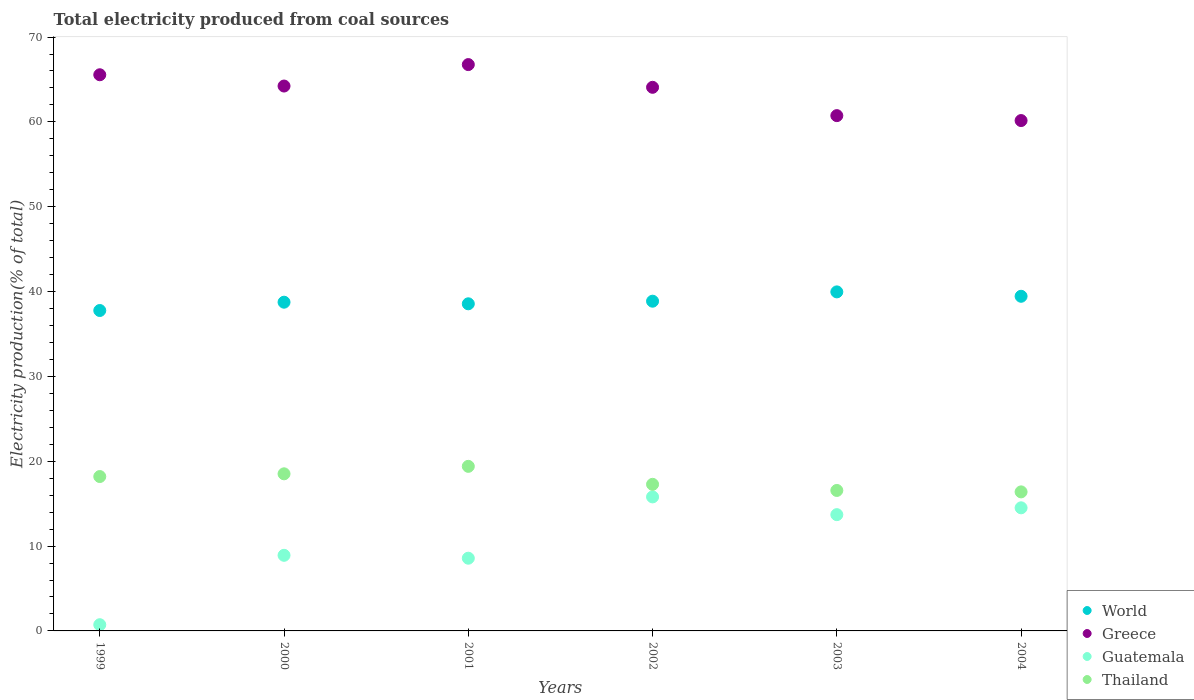Is the number of dotlines equal to the number of legend labels?
Your response must be concise. Yes. What is the total electricity produced in Guatemala in 2000?
Keep it short and to the point. 8.91. Across all years, what is the maximum total electricity produced in Guatemala?
Provide a short and direct response. 15.8. Across all years, what is the minimum total electricity produced in Thailand?
Your answer should be very brief. 16.39. In which year was the total electricity produced in Guatemala maximum?
Ensure brevity in your answer.  2002. In which year was the total electricity produced in World minimum?
Your response must be concise. 1999. What is the total total electricity produced in Guatemala in the graph?
Give a very brief answer. 62.23. What is the difference between the total electricity produced in Thailand in 1999 and that in 2004?
Provide a succinct answer. 1.81. What is the difference between the total electricity produced in Guatemala in 2004 and the total electricity produced in Thailand in 2002?
Make the answer very short. -2.77. What is the average total electricity produced in Thailand per year?
Offer a terse response. 17.72. In the year 2002, what is the difference between the total electricity produced in Guatemala and total electricity produced in Thailand?
Make the answer very short. -1.48. In how many years, is the total electricity produced in Guatemala greater than 42 %?
Give a very brief answer. 0. What is the ratio of the total electricity produced in Guatemala in 2002 to that in 2004?
Offer a terse response. 1.09. Is the total electricity produced in Greece in 2000 less than that in 2002?
Keep it short and to the point. No. Is the difference between the total electricity produced in Guatemala in 2000 and 2001 greater than the difference between the total electricity produced in Thailand in 2000 and 2001?
Offer a very short reply. Yes. What is the difference between the highest and the second highest total electricity produced in Guatemala?
Offer a terse response. 1.29. What is the difference between the highest and the lowest total electricity produced in Thailand?
Offer a terse response. 3.01. Is it the case that in every year, the sum of the total electricity produced in Thailand and total electricity produced in World  is greater than the sum of total electricity produced in Greece and total electricity produced in Guatemala?
Your answer should be compact. Yes. Is the total electricity produced in Guatemala strictly less than the total electricity produced in World over the years?
Your response must be concise. Yes. How many dotlines are there?
Make the answer very short. 4. How many years are there in the graph?
Provide a short and direct response. 6. Does the graph contain grids?
Offer a very short reply. No. Where does the legend appear in the graph?
Offer a very short reply. Bottom right. How many legend labels are there?
Your answer should be very brief. 4. What is the title of the graph?
Make the answer very short. Total electricity produced from coal sources. Does "Lesotho" appear as one of the legend labels in the graph?
Provide a succinct answer. No. What is the Electricity production(% of total) of World in 1999?
Provide a succinct answer. 37.77. What is the Electricity production(% of total) in Greece in 1999?
Provide a succinct answer. 65.56. What is the Electricity production(% of total) of Guatemala in 1999?
Give a very brief answer. 0.73. What is the Electricity production(% of total) in Thailand in 1999?
Your answer should be very brief. 18.2. What is the Electricity production(% of total) of World in 2000?
Provide a short and direct response. 38.75. What is the Electricity production(% of total) in Greece in 2000?
Your answer should be compact. 64.23. What is the Electricity production(% of total) in Guatemala in 2000?
Your answer should be compact. 8.91. What is the Electricity production(% of total) in Thailand in 2000?
Your answer should be very brief. 18.52. What is the Electricity production(% of total) of World in 2001?
Keep it short and to the point. 38.56. What is the Electricity production(% of total) of Greece in 2001?
Make the answer very short. 66.76. What is the Electricity production(% of total) in Guatemala in 2001?
Make the answer very short. 8.57. What is the Electricity production(% of total) in Thailand in 2001?
Make the answer very short. 19.4. What is the Electricity production(% of total) in World in 2002?
Make the answer very short. 38.86. What is the Electricity production(% of total) of Greece in 2002?
Your answer should be very brief. 64.08. What is the Electricity production(% of total) in Guatemala in 2002?
Your answer should be very brief. 15.8. What is the Electricity production(% of total) of Thailand in 2002?
Your response must be concise. 17.28. What is the Electricity production(% of total) in World in 2003?
Your answer should be compact. 39.96. What is the Electricity production(% of total) in Greece in 2003?
Your answer should be very brief. 60.74. What is the Electricity production(% of total) in Guatemala in 2003?
Make the answer very short. 13.71. What is the Electricity production(% of total) of Thailand in 2003?
Your answer should be very brief. 16.56. What is the Electricity production(% of total) of World in 2004?
Your answer should be very brief. 39.44. What is the Electricity production(% of total) in Greece in 2004?
Your answer should be very brief. 60.16. What is the Electricity production(% of total) in Guatemala in 2004?
Give a very brief answer. 14.51. What is the Electricity production(% of total) of Thailand in 2004?
Provide a succinct answer. 16.39. Across all years, what is the maximum Electricity production(% of total) in World?
Provide a short and direct response. 39.96. Across all years, what is the maximum Electricity production(% of total) of Greece?
Keep it short and to the point. 66.76. Across all years, what is the maximum Electricity production(% of total) of Guatemala?
Your response must be concise. 15.8. Across all years, what is the maximum Electricity production(% of total) in Thailand?
Provide a short and direct response. 19.4. Across all years, what is the minimum Electricity production(% of total) of World?
Your response must be concise. 37.77. Across all years, what is the minimum Electricity production(% of total) of Greece?
Ensure brevity in your answer.  60.16. Across all years, what is the minimum Electricity production(% of total) in Guatemala?
Provide a succinct answer. 0.73. Across all years, what is the minimum Electricity production(% of total) of Thailand?
Give a very brief answer. 16.39. What is the total Electricity production(% of total) in World in the graph?
Provide a short and direct response. 233.34. What is the total Electricity production(% of total) in Greece in the graph?
Your answer should be very brief. 381.51. What is the total Electricity production(% of total) in Guatemala in the graph?
Keep it short and to the point. 62.23. What is the total Electricity production(% of total) in Thailand in the graph?
Your answer should be compact. 106.34. What is the difference between the Electricity production(% of total) of World in 1999 and that in 2000?
Your answer should be compact. -0.98. What is the difference between the Electricity production(% of total) in Greece in 1999 and that in 2000?
Provide a short and direct response. 1.33. What is the difference between the Electricity production(% of total) in Guatemala in 1999 and that in 2000?
Offer a terse response. -8.18. What is the difference between the Electricity production(% of total) of Thailand in 1999 and that in 2000?
Your answer should be compact. -0.32. What is the difference between the Electricity production(% of total) in World in 1999 and that in 2001?
Offer a terse response. -0.79. What is the difference between the Electricity production(% of total) of Greece in 1999 and that in 2001?
Provide a short and direct response. -1.2. What is the difference between the Electricity production(% of total) of Guatemala in 1999 and that in 2001?
Ensure brevity in your answer.  -7.84. What is the difference between the Electricity production(% of total) in Thailand in 1999 and that in 2001?
Your answer should be compact. -1.2. What is the difference between the Electricity production(% of total) in World in 1999 and that in 2002?
Give a very brief answer. -1.1. What is the difference between the Electricity production(% of total) of Greece in 1999 and that in 2002?
Ensure brevity in your answer.  1.48. What is the difference between the Electricity production(% of total) of Guatemala in 1999 and that in 2002?
Ensure brevity in your answer.  -15.06. What is the difference between the Electricity production(% of total) in Thailand in 1999 and that in 2002?
Give a very brief answer. 0.92. What is the difference between the Electricity production(% of total) of World in 1999 and that in 2003?
Offer a very short reply. -2.19. What is the difference between the Electricity production(% of total) of Greece in 1999 and that in 2003?
Keep it short and to the point. 4.82. What is the difference between the Electricity production(% of total) of Guatemala in 1999 and that in 2003?
Provide a succinct answer. -12.97. What is the difference between the Electricity production(% of total) of Thailand in 1999 and that in 2003?
Provide a short and direct response. 1.64. What is the difference between the Electricity production(% of total) of World in 1999 and that in 2004?
Your response must be concise. -1.68. What is the difference between the Electricity production(% of total) of Greece in 1999 and that in 2004?
Give a very brief answer. 5.4. What is the difference between the Electricity production(% of total) of Guatemala in 1999 and that in 2004?
Keep it short and to the point. -13.78. What is the difference between the Electricity production(% of total) of Thailand in 1999 and that in 2004?
Your answer should be compact. 1.81. What is the difference between the Electricity production(% of total) in World in 2000 and that in 2001?
Provide a short and direct response. 0.19. What is the difference between the Electricity production(% of total) in Greece in 2000 and that in 2001?
Make the answer very short. -2.53. What is the difference between the Electricity production(% of total) in Guatemala in 2000 and that in 2001?
Provide a short and direct response. 0.34. What is the difference between the Electricity production(% of total) of Thailand in 2000 and that in 2001?
Provide a short and direct response. -0.88. What is the difference between the Electricity production(% of total) in World in 2000 and that in 2002?
Offer a very short reply. -0.12. What is the difference between the Electricity production(% of total) of Greece in 2000 and that in 2002?
Provide a short and direct response. 0.15. What is the difference between the Electricity production(% of total) of Guatemala in 2000 and that in 2002?
Make the answer very short. -6.89. What is the difference between the Electricity production(% of total) of Thailand in 2000 and that in 2002?
Keep it short and to the point. 1.24. What is the difference between the Electricity production(% of total) of World in 2000 and that in 2003?
Make the answer very short. -1.22. What is the difference between the Electricity production(% of total) of Greece in 2000 and that in 2003?
Your answer should be very brief. 3.49. What is the difference between the Electricity production(% of total) of Guatemala in 2000 and that in 2003?
Your answer should be very brief. -4.79. What is the difference between the Electricity production(% of total) of Thailand in 2000 and that in 2003?
Offer a very short reply. 1.96. What is the difference between the Electricity production(% of total) in World in 2000 and that in 2004?
Ensure brevity in your answer.  -0.7. What is the difference between the Electricity production(% of total) in Greece in 2000 and that in 2004?
Give a very brief answer. 4.07. What is the difference between the Electricity production(% of total) of Guatemala in 2000 and that in 2004?
Ensure brevity in your answer.  -5.6. What is the difference between the Electricity production(% of total) in Thailand in 2000 and that in 2004?
Your answer should be very brief. 2.13. What is the difference between the Electricity production(% of total) of World in 2001 and that in 2002?
Your response must be concise. -0.31. What is the difference between the Electricity production(% of total) of Greece in 2001 and that in 2002?
Provide a short and direct response. 2.68. What is the difference between the Electricity production(% of total) in Guatemala in 2001 and that in 2002?
Offer a very short reply. -7.23. What is the difference between the Electricity production(% of total) of Thailand in 2001 and that in 2002?
Your answer should be very brief. 2.12. What is the difference between the Electricity production(% of total) of World in 2001 and that in 2003?
Offer a terse response. -1.4. What is the difference between the Electricity production(% of total) in Greece in 2001 and that in 2003?
Your response must be concise. 6.02. What is the difference between the Electricity production(% of total) of Guatemala in 2001 and that in 2003?
Ensure brevity in your answer.  -5.13. What is the difference between the Electricity production(% of total) of Thailand in 2001 and that in 2003?
Provide a succinct answer. 2.84. What is the difference between the Electricity production(% of total) in World in 2001 and that in 2004?
Ensure brevity in your answer.  -0.89. What is the difference between the Electricity production(% of total) of Greece in 2001 and that in 2004?
Keep it short and to the point. 6.6. What is the difference between the Electricity production(% of total) of Guatemala in 2001 and that in 2004?
Your answer should be very brief. -5.94. What is the difference between the Electricity production(% of total) in Thailand in 2001 and that in 2004?
Your response must be concise. 3.01. What is the difference between the Electricity production(% of total) in World in 2002 and that in 2003?
Offer a very short reply. -1.1. What is the difference between the Electricity production(% of total) of Greece in 2002 and that in 2003?
Ensure brevity in your answer.  3.34. What is the difference between the Electricity production(% of total) of Guatemala in 2002 and that in 2003?
Provide a short and direct response. 2.09. What is the difference between the Electricity production(% of total) of Thailand in 2002 and that in 2003?
Your answer should be very brief. 0.72. What is the difference between the Electricity production(% of total) of World in 2002 and that in 2004?
Give a very brief answer. -0.58. What is the difference between the Electricity production(% of total) of Greece in 2002 and that in 2004?
Provide a succinct answer. 3.92. What is the difference between the Electricity production(% of total) of Guatemala in 2002 and that in 2004?
Offer a terse response. 1.29. What is the difference between the Electricity production(% of total) in Thailand in 2002 and that in 2004?
Your answer should be compact. 0.89. What is the difference between the Electricity production(% of total) of World in 2003 and that in 2004?
Offer a very short reply. 0.52. What is the difference between the Electricity production(% of total) of Greece in 2003 and that in 2004?
Keep it short and to the point. 0.58. What is the difference between the Electricity production(% of total) in Guatemala in 2003 and that in 2004?
Provide a succinct answer. -0.81. What is the difference between the Electricity production(% of total) in Thailand in 2003 and that in 2004?
Provide a succinct answer. 0.17. What is the difference between the Electricity production(% of total) of World in 1999 and the Electricity production(% of total) of Greece in 2000?
Give a very brief answer. -26.46. What is the difference between the Electricity production(% of total) in World in 1999 and the Electricity production(% of total) in Guatemala in 2000?
Provide a short and direct response. 28.86. What is the difference between the Electricity production(% of total) of World in 1999 and the Electricity production(% of total) of Thailand in 2000?
Provide a succinct answer. 19.25. What is the difference between the Electricity production(% of total) in Greece in 1999 and the Electricity production(% of total) in Guatemala in 2000?
Your answer should be very brief. 56.64. What is the difference between the Electricity production(% of total) of Greece in 1999 and the Electricity production(% of total) of Thailand in 2000?
Offer a terse response. 47.04. What is the difference between the Electricity production(% of total) of Guatemala in 1999 and the Electricity production(% of total) of Thailand in 2000?
Keep it short and to the point. -17.78. What is the difference between the Electricity production(% of total) of World in 1999 and the Electricity production(% of total) of Greece in 2001?
Give a very brief answer. -28.99. What is the difference between the Electricity production(% of total) in World in 1999 and the Electricity production(% of total) in Guatemala in 2001?
Offer a terse response. 29.2. What is the difference between the Electricity production(% of total) in World in 1999 and the Electricity production(% of total) in Thailand in 2001?
Keep it short and to the point. 18.37. What is the difference between the Electricity production(% of total) of Greece in 1999 and the Electricity production(% of total) of Guatemala in 2001?
Provide a succinct answer. 56.98. What is the difference between the Electricity production(% of total) of Greece in 1999 and the Electricity production(% of total) of Thailand in 2001?
Ensure brevity in your answer.  46.16. What is the difference between the Electricity production(% of total) in Guatemala in 1999 and the Electricity production(% of total) in Thailand in 2001?
Provide a short and direct response. -18.67. What is the difference between the Electricity production(% of total) of World in 1999 and the Electricity production(% of total) of Greece in 2002?
Ensure brevity in your answer.  -26.31. What is the difference between the Electricity production(% of total) of World in 1999 and the Electricity production(% of total) of Guatemala in 2002?
Give a very brief answer. 21.97. What is the difference between the Electricity production(% of total) in World in 1999 and the Electricity production(% of total) in Thailand in 2002?
Provide a succinct answer. 20.49. What is the difference between the Electricity production(% of total) of Greece in 1999 and the Electricity production(% of total) of Guatemala in 2002?
Your answer should be compact. 49.76. What is the difference between the Electricity production(% of total) in Greece in 1999 and the Electricity production(% of total) in Thailand in 2002?
Keep it short and to the point. 48.28. What is the difference between the Electricity production(% of total) in Guatemala in 1999 and the Electricity production(% of total) in Thailand in 2002?
Keep it short and to the point. -16.55. What is the difference between the Electricity production(% of total) in World in 1999 and the Electricity production(% of total) in Greece in 2003?
Your answer should be compact. -22.97. What is the difference between the Electricity production(% of total) in World in 1999 and the Electricity production(% of total) in Guatemala in 2003?
Give a very brief answer. 24.06. What is the difference between the Electricity production(% of total) of World in 1999 and the Electricity production(% of total) of Thailand in 2003?
Your answer should be very brief. 21.21. What is the difference between the Electricity production(% of total) in Greece in 1999 and the Electricity production(% of total) in Guatemala in 2003?
Offer a terse response. 51.85. What is the difference between the Electricity production(% of total) of Greece in 1999 and the Electricity production(% of total) of Thailand in 2003?
Give a very brief answer. 49. What is the difference between the Electricity production(% of total) of Guatemala in 1999 and the Electricity production(% of total) of Thailand in 2003?
Your answer should be very brief. -15.82. What is the difference between the Electricity production(% of total) of World in 1999 and the Electricity production(% of total) of Greece in 2004?
Make the answer very short. -22.39. What is the difference between the Electricity production(% of total) of World in 1999 and the Electricity production(% of total) of Guatemala in 2004?
Offer a very short reply. 23.26. What is the difference between the Electricity production(% of total) of World in 1999 and the Electricity production(% of total) of Thailand in 2004?
Keep it short and to the point. 21.38. What is the difference between the Electricity production(% of total) in Greece in 1999 and the Electricity production(% of total) in Guatemala in 2004?
Offer a very short reply. 51.04. What is the difference between the Electricity production(% of total) of Greece in 1999 and the Electricity production(% of total) of Thailand in 2004?
Provide a succinct answer. 49.17. What is the difference between the Electricity production(% of total) of Guatemala in 1999 and the Electricity production(% of total) of Thailand in 2004?
Your answer should be very brief. -15.66. What is the difference between the Electricity production(% of total) in World in 2000 and the Electricity production(% of total) in Greece in 2001?
Ensure brevity in your answer.  -28.01. What is the difference between the Electricity production(% of total) of World in 2000 and the Electricity production(% of total) of Guatemala in 2001?
Provide a succinct answer. 30.18. What is the difference between the Electricity production(% of total) of World in 2000 and the Electricity production(% of total) of Thailand in 2001?
Your response must be concise. 19.35. What is the difference between the Electricity production(% of total) in Greece in 2000 and the Electricity production(% of total) in Guatemala in 2001?
Provide a succinct answer. 55.66. What is the difference between the Electricity production(% of total) of Greece in 2000 and the Electricity production(% of total) of Thailand in 2001?
Your answer should be very brief. 44.83. What is the difference between the Electricity production(% of total) in Guatemala in 2000 and the Electricity production(% of total) in Thailand in 2001?
Your answer should be very brief. -10.49. What is the difference between the Electricity production(% of total) of World in 2000 and the Electricity production(% of total) of Greece in 2002?
Ensure brevity in your answer.  -25.33. What is the difference between the Electricity production(% of total) of World in 2000 and the Electricity production(% of total) of Guatemala in 2002?
Keep it short and to the point. 22.95. What is the difference between the Electricity production(% of total) in World in 2000 and the Electricity production(% of total) in Thailand in 2002?
Keep it short and to the point. 21.47. What is the difference between the Electricity production(% of total) of Greece in 2000 and the Electricity production(% of total) of Guatemala in 2002?
Your response must be concise. 48.43. What is the difference between the Electricity production(% of total) of Greece in 2000 and the Electricity production(% of total) of Thailand in 2002?
Your answer should be very brief. 46.95. What is the difference between the Electricity production(% of total) of Guatemala in 2000 and the Electricity production(% of total) of Thailand in 2002?
Ensure brevity in your answer.  -8.37. What is the difference between the Electricity production(% of total) in World in 2000 and the Electricity production(% of total) in Greece in 2003?
Your answer should be compact. -21.99. What is the difference between the Electricity production(% of total) in World in 2000 and the Electricity production(% of total) in Guatemala in 2003?
Your answer should be compact. 25.04. What is the difference between the Electricity production(% of total) in World in 2000 and the Electricity production(% of total) in Thailand in 2003?
Your answer should be compact. 22.19. What is the difference between the Electricity production(% of total) of Greece in 2000 and the Electricity production(% of total) of Guatemala in 2003?
Keep it short and to the point. 50.52. What is the difference between the Electricity production(% of total) of Greece in 2000 and the Electricity production(% of total) of Thailand in 2003?
Make the answer very short. 47.67. What is the difference between the Electricity production(% of total) of Guatemala in 2000 and the Electricity production(% of total) of Thailand in 2003?
Your answer should be compact. -7.65. What is the difference between the Electricity production(% of total) of World in 2000 and the Electricity production(% of total) of Greece in 2004?
Offer a very short reply. -21.41. What is the difference between the Electricity production(% of total) of World in 2000 and the Electricity production(% of total) of Guatemala in 2004?
Your response must be concise. 24.24. What is the difference between the Electricity production(% of total) in World in 2000 and the Electricity production(% of total) in Thailand in 2004?
Keep it short and to the point. 22.36. What is the difference between the Electricity production(% of total) of Greece in 2000 and the Electricity production(% of total) of Guatemala in 2004?
Ensure brevity in your answer.  49.72. What is the difference between the Electricity production(% of total) of Greece in 2000 and the Electricity production(% of total) of Thailand in 2004?
Provide a short and direct response. 47.84. What is the difference between the Electricity production(% of total) of Guatemala in 2000 and the Electricity production(% of total) of Thailand in 2004?
Make the answer very short. -7.48. What is the difference between the Electricity production(% of total) in World in 2001 and the Electricity production(% of total) in Greece in 2002?
Keep it short and to the point. -25.52. What is the difference between the Electricity production(% of total) of World in 2001 and the Electricity production(% of total) of Guatemala in 2002?
Provide a succinct answer. 22.76. What is the difference between the Electricity production(% of total) in World in 2001 and the Electricity production(% of total) in Thailand in 2002?
Make the answer very short. 21.28. What is the difference between the Electricity production(% of total) in Greece in 2001 and the Electricity production(% of total) in Guatemala in 2002?
Make the answer very short. 50.96. What is the difference between the Electricity production(% of total) of Greece in 2001 and the Electricity production(% of total) of Thailand in 2002?
Give a very brief answer. 49.48. What is the difference between the Electricity production(% of total) in Guatemala in 2001 and the Electricity production(% of total) in Thailand in 2002?
Provide a succinct answer. -8.71. What is the difference between the Electricity production(% of total) in World in 2001 and the Electricity production(% of total) in Greece in 2003?
Make the answer very short. -22.18. What is the difference between the Electricity production(% of total) of World in 2001 and the Electricity production(% of total) of Guatemala in 2003?
Your response must be concise. 24.85. What is the difference between the Electricity production(% of total) in World in 2001 and the Electricity production(% of total) in Thailand in 2003?
Give a very brief answer. 22. What is the difference between the Electricity production(% of total) of Greece in 2001 and the Electricity production(% of total) of Guatemala in 2003?
Keep it short and to the point. 53.05. What is the difference between the Electricity production(% of total) in Greece in 2001 and the Electricity production(% of total) in Thailand in 2003?
Offer a very short reply. 50.2. What is the difference between the Electricity production(% of total) of Guatemala in 2001 and the Electricity production(% of total) of Thailand in 2003?
Your answer should be very brief. -7.99. What is the difference between the Electricity production(% of total) in World in 2001 and the Electricity production(% of total) in Greece in 2004?
Provide a succinct answer. -21.6. What is the difference between the Electricity production(% of total) of World in 2001 and the Electricity production(% of total) of Guatemala in 2004?
Offer a very short reply. 24.05. What is the difference between the Electricity production(% of total) in World in 2001 and the Electricity production(% of total) in Thailand in 2004?
Your answer should be compact. 22.17. What is the difference between the Electricity production(% of total) of Greece in 2001 and the Electricity production(% of total) of Guatemala in 2004?
Your answer should be compact. 52.24. What is the difference between the Electricity production(% of total) in Greece in 2001 and the Electricity production(% of total) in Thailand in 2004?
Provide a succinct answer. 50.37. What is the difference between the Electricity production(% of total) of Guatemala in 2001 and the Electricity production(% of total) of Thailand in 2004?
Provide a succinct answer. -7.82. What is the difference between the Electricity production(% of total) of World in 2002 and the Electricity production(% of total) of Greece in 2003?
Your response must be concise. -21.87. What is the difference between the Electricity production(% of total) in World in 2002 and the Electricity production(% of total) in Guatemala in 2003?
Provide a succinct answer. 25.16. What is the difference between the Electricity production(% of total) of World in 2002 and the Electricity production(% of total) of Thailand in 2003?
Provide a succinct answer. 22.31. What is the difference between the Electricity production(% of total) of Greece in 2002 and the Electricity production(% of total) of Guatemala in 2003?
Your answer should be compact. 50.37. What is the difference between the Electricity production(% of total) of Greece in 2002 and the Electricity production(% of total) of Thailand in 2003?
Your response must be concise. 47.52. What is the difference between the Electricity production(% of total) of Guatemala in 2002 and the Electricity production(% of total) of Thailand in 2003?
Offer a very short reply. -0.76. What is the difference between the Electricity production(% of total) in World in 2002 and the Electricity production(% of total) in Greece in 2004?
Give a very brief answer. -21.29. What is the difference between the Electricity production(% of total) of World in 2002 and the Electricity production(% of total) of Guatemala in 2004?
Offer a terse response. 24.35. What is the difference between the Electricity production(% of total) in World in 2002 and the Electricity production(% of total) in Thailand in 2004?
Provide a short and direct response. 22.48. What is the difference between the Electricity production(% of total) in Greece in 2002 and the Electricity production(% of total) in Guatemala in 2004?
Your answer should be compact. 49.57. What is the difference between the Electricity production(% of total) of Greece in 2002 and the Electricity production(% of total) of Thailand in 2004?
Your response must be concise. 47.69. What is the difference between the Electricity production(% of total) of Guatemala in 2002 and the Electricity production(% of total) of Thailand in 2004?
Offer a terse response. -0.59. What is the difference between the Electricity production(% of total) of World in 2003 and the Electricity production(% of total) of Greece in 2004?
Offer a terse response. -20.19. What is the difference between the Electricity production(% of total) of World in 2003 and the Electricity production(% of total) of Guatemala in 2004?
Give a very brief answer. 25.45. What is the difference between the Electricity production(% of total) of World in 2003 and the Electricity production(% of total) of Thailand in 2004?
Provide a short and direct response. 23.57. What is the difference between the Electricity production(% of total) of Greece in 2003 and the Electricity production(% of total) of Guatemala in 2004?
Ensure brevity in your answer.  46.23. What is the difference between the Electricity production(% of total) in Greece in 2003 and the Electricity production(% of total) in Thailand in 2004?
Give a very brief answer. 44.35. What is the difference between the Electricity production(% of total) in Guatemala in 2003 and the Electricity production(% of total) in Thailand in 2004?
Provide a short and direct response. -2.68. What is the average Electricity production(% of total) in World per year?
Provide a succinct answer. 38.89. What is the average Electricity production(% of total) in Greece per year?
Keep it short and to the point. 63.58. What is the average Electricity production(% of total) of Guatemala per year?
Your answer should be compact. 10.37. What is the average Electricity production(% of total) of Thailand per year?
Offer a very short reply. 17.72. In the year 1999, what is the difference between the Electricity production(% of total) of World and Electricity production(% of total) of Greece?
Offer a very short reply. -27.79. In the year 1999, what is the difference between the Electricity production(% of total) of World and Electricity production(% of total) of Guatemala?
Keep it short and to the point. 37.03. In the year 1999, what is the difference between the Electricity production(% of total) of World and Electricity production(% of total) of Thailand?
Give a very brief answer. 19.57. In the year 1999, what is the difference between the Electricity production(% of total) of Greece and Electricity production(% of total) of Guatemala?
Your answer should be very brief. 64.82. In the year 1999, what is the difference between the Electricity production(% of total) of Greece and Electricity production(% of total) of Thailand?
Keep it short and to the point. 47.36. In the year 1999, what is the difference between the Electricity production(% of total) in Guatemala and Electricity production(% of total) in Thailand?
Keep it short and to the point. -17.46. In the year 2000, what is the difference between the Electricity production(% of total) in World and Electricity production(% of total) in Greece?
Your response must be concise. -25.48. In the year 2000, what is the difference between the Electricity production(% of total) of World and Electricity production(% of total) of Guatemala?
Your answer should be very brief. 29.83. In the year 2000, what is the difference between the Electricity production(% of total) in World and Electricity production(% of total) in Thailand?
Keep it short and to the point. 20.23. In the year 2000, what is the difference between the Electricity production(% of total) in Greece and Electricity production(% of total) in Guatemala?
Your answer should be very brief. 55.31. In the year 2000, what is the difference between the Electricity production(% of total) of Greece and Electricity production(% of total) of Thailand?
Your answer should be compact. 45.71. In the year 2000, what is the difference between the Electricity production(% of total) of Guatemala and Electricity production(% of total) of Thailand?
Make the answer very short. -9.61. In the year 2001, what is the difference between the Electricity production(% of total) of World and Electricity production(% of total) of Greece?
Your answer should be compact. -28.2. In the year 2001, what is the difference between the Electricity production(% of total) of World and Electricity production(% of total) of Guatemala?
Ensure brevity in your answer.  29.99. In the year 2001, what is the difference between the Electricity production(% of total) of World and Electricity production(% of total) of Thailand?
Offer a very short reply. 19.16. In the year 2001, what is the difference between the Electricity production(% of total) of Greece and Electricity production(% of total) of Guatemala?
Ensure brevity in your answer.  58.18. In the year 2001, what is the difference between the Electricity production(% of total) of Greece and Electricity production(% of total) of Thailand?
Give a very brief answer. 47.36. In the year 2001, what is the difference between the Electricity production(% of total) of Guatemala and Electricity production(% of total) of Thailand?
Your answer should be very brief. -10.83. In the year 2002, what is the difference between the Electricity production(% of total) in World and Electricity production(% of total) in Greece?
Make the answer very short. -25.21. In the year 2002, what is the difference between the Electricity production(% of total) of World and Electricity production(% of total) of Guatemala?
Make the answer very short. 23.07. In the year 2002, what is the difference between the Electricity production(% of total) in World and Electricity production(% of total) in Thailand?
Provide a succinct answer. 21.59. In the year 2002, what is the difference between the Electricity production(% of total) in Greece and Electricity production(% of total) in Guatemala?
Offer a very short reply. 48.28. In the year 2002, what is the difference between the Electricity production(% of total) in Greece and Electricity production(% of total) in Thailand?
Your response must be concise. 46.8. In the year 2002, what is the difference between the Electricity production(% of total) of Guatemala and Electricity production(% of total) of Thailand?
Offer a very short reply. -1.48. In the year 2003, what is the difference between the Electricity production(% of total) in World and Electricity production(% of total) in Greece?
Provide a succinct answer. -20.77. In the year 2003, what is the difference between the Electricity production(% of total) in World and Electricity production(% of total) in Guatemala?
Ensure brevity in your answer.  26.26. In the year 2003, what is the difference between the Electricity production(% of total) in World and Electricity production(% of total) in Thailand?
Offer a very short reply. 23.41. In the year 2003, what is the difference between the Electricity production(% of total) in Greece and Electricity production(% of total) in Guatemala?
Ensure brevity in your answer.  47.03. In the year 2003, what is the difference between the Electricity production(% of total) in Greece and Electricity production(% of total) in Thailand?
Your answer should be compact. 44.18. In the year 2003, what is the difference between the Electricity production(% of total) of Guatemala and Electricity production(% of total) of Thailand?
Keep it short and to the point. -2.85. In the year 2004, what is the difference between the Electricity production(% of total) of World and Electricity production(% of total) of Greece?
Offer a terse response. -20.71. In the year 2004, what is the difference between the Electricity production(% of total) of World and Electricity production(% of total) of Guatemala?
Your answer should be very brief. 24.93. In the year 2004, what is the difference between the Electricity production(% of total) in World and Electricity production(% of total) in Thailand?
Offer a very short reply. 23.06. In the year 2004, what is the difference between the Electricity production(% of total) of Greece and Electricity production(% of total) of Guatemala?
Offer a terse response. 45.65. In the year 2004, what is the difference between the Electricity production(% of total) of Greece and Electricity production(% of total) of Thailand?
Ensure brevity in your answer.  43.77. In the year 2004, what is the difference between the Electricity production(% of total) in Guatemala and Electricity production(% of total) in Thailand?
Ensure brevity in your answer.  -1.88. What is the ratio of the Electricity production(% of total) of World in 1999 to that in 2000?
Provide a succinct answer. 0.97. What is the ratio of the Electricity production(% of total) of Greece in 1999 to that in 2000?
Your answer should be very brief. 1.02. What is the ratio of the Electricity production(% of total) of Guatemala in 1999 to that in 2000?
Offer a terse response. 0.08. What is the ratio of the Electricity production(% of total) of Thailand in 1999 to that in 2000?
Provide a succinct answer. 0.98. What is the ratio of the Electricity production(% of total) in World in 1999 to that in 2001?
Provide a short and direct response. 0.98. What is the ratio of the Electricity production(% of total) in Greece in 1999 to that in 2001?
Your answer should be very brief. 0.98. What is the ratio of the Electricity production(% of total) of Guatemala in 1999 to that in 2001?
Your response must be concise. 0.09. What is the ratio of the Electricity production(% of total) of Thailand in 1999 to that in 2001?
Offer a very short reply. 0.94. What is the ratio of the Electricity production(% of total) of World in 1999 to that in 2002?
Your answer should be compact. 0.97. What is the ratio of the Electricity production(% of total) of Greece in 1999 to that in 2002?
Give a very brief answer. 1.02. What is the ratio of the Electricity production(% of total) in Guatemala in 1999 to that in 2002?
Ensure brevity in your answer.  0.05. What is the ratio of the Electricity production(% of total) in Thailand in 1999 to that in 2002?
Provide a short and direct response. 1.05. What is the ratio of the Electricity production(% of total) in World in 1999 to that in 2003?
Your answer should be compact. 0.95. What is the ratio of the Electricity production(% of total) in Greece in 1999 to that in 2003?
Your response must be concise. 1.08. What is the ratio of the Electricity production(% of total) in Guatemala in 1999 to that in 2003?
Provide a short and direct response. 0.05. What is the ratio of the Electricity production(% of total) of Thailand in 1999 to that in 2003?
Give a very brief answer. 1.1. What is the ratio of the Electricity production(% of total) of World in 1999 to that in 2004?
Provide a succinct answer. 0.96. What is the ratio of the Electricity production(% of total) in Greece in 1999 to that in 2004?
Keep it short and to the point. 1.09. What is the ratio of the Electricity production(% of total) in Guatemala in 1999 to that in 2004?
Your answer should be compact. 0.05. What is the ratio of the Electricity production(% of total) of Thailand in 1999 to that in 2004?
Give a very brief answer. 1.11. What is the ratio of the Electricity production(% of total) in World in 2000 to that in 2001?
Provide a succinct answer. 1. What is the ratio of the Electricity production(% of total) in Greece in 2000 to that in 2001?
Ensure brevity in your answer.  0.96. What is the ratio of the Electricity production(% of total) in Guatemala in 2000 to that in 2001?
Keep it short and to the point. 1.04. What is the ratio of the Electricity production(% of total) in Thailand in 2000 to that in 2001?
Make the answer very short. 0.95. What is the ratio of the Electricity production(% of total) of Greece in 2000 to that in 2002?
Provide a succinct answer. 1. What is the ratio of the Electricity production(% of total) of Guatemala in 2000 to that in 2002?
Give a very brief answer. 0.56. What is the ratio of the Electricity production(% of total) of Thailand in 2000 to that in 2002?
Your response must be concise. 1.07. What is the ratio of the Electricity production(% of total) in World in 2000 to that in 2003?
Make the answer very short. 0.97. What is the ratio of the Electricity production(% of total) of Greece in 2000 to that in 2003?
Your answer should be compact. 1.06. What is the ratio of the Electricity production(% of total) in Guatemala in 2000 to that in 2003?
Your answer should be compact. 0.65. What is the ratio of the Electricity production(% of total) in Thailand in 2000 to that in 2003?
Ensure brevity in your answer.  1.12. What is the ratio of the Electricity production(% of total) in World in 2000 to that in 2004?
Your answer should be very brief. 0.98. What is the ratio of the Electricity production(% of total) in Greece in 2000 to that in 2004?
Ensure brevity in your answer.  1.07. What is the ratio of the Electricity production(% of total) of Guatemala in 2000 to that in 2004?
Your response must be concise. 0.61. What is the ratio of the Electricity production(% of total) in Thailand in 2000 to that in 2004?
Make the answer very short. 1.13. What is the ratio of the Electricity production(% of total) of World in 2001 to that in 2002?
Your answer should be compact. 0.99. What is the ratio of the Electricity production(% of total) of Greece in 2001 to that in 2002?
Provide a succinct answer. 1.04. What is the ratio of the Electricity production(% of total) in Guatemala in 2001 to that in 2002?
Make the answer very short. 0.54. What is the ratio of the Electricity production(% of total) of Thailand in 2001 to that in 2002?
Offer a terse response. 1.12. What is the ratio of the Electricity production(% of total) in World in 2001 to that in 2003?
Give a very brief answer. 0.96. What is the ratio of the Electricity production(% of total) in Greece in 2001 to that in 2003?
Provide a succinct answer. 1.1. What is the ratio of the Electricity production(% of total) in Guatemala in 2001 to that in 2003?
Ensure brevity in your answer.  0.63. What is the ratio of the Electricity production(% of total) of Thailand in 2001 to that in 2003?
Offer a terse response. 1.17. What is the ratio of the Electricity production(% of total) of World in 2001 to that in 2004?
Your answer should be compact. 0.98. What is the ratio of the Electricity production(% of total) in Greece in 2001 to that in 2004?
Your answer should be compact. 1.11. What is the ratio of the Electricity production(% of total) of Guatemala in 2001 to that in 2004?
Provide a succinct answer. 0.59. What is the ratio of the Electricity production(% of total) of Thailand in 2001 to that in 2004?
Your answer should be compact. 1.18. What is the ratio of the Electricity production(% of total) of World in 2002 to that in 2003?
Provide a succinct answer. 0.97. What is the ratio of the Electricity production(% of total) in Greece in 2002 to that in 2003?
Keep it short and to the point. 1.05. What is the ratio of the Electricity production(% of total) of Guatemala in 2002 to that in 2003?
Make the answer very short. 1.15. What is the ratio of the Electricity production(% of total) in Thailand in 2002 to that in 2003?
Your answer should be very brief. 1.04. What is the ratio of the Electricity production(% of total) in World in 2002 to that in 2004?
Offer a very short reply. 0.99. What is the ratio of the Electricity production(% of total) in Greece in 2002 to that in 2004?
Provide a short and direct response. 1.07. What is the ratio of the Electricity production(% of total) of Guatemala in 2002 to that in 2004?
Provide a succinct answer. 1.09. What is the ratio of the Electricity production(% of total) in Thailand in 2002 to that in 2004?
Your answer should be compact. 1.05. What is the ratio of the Electricity production(% of total) of World in 2003 to that in 2004?
Offer a terse response. 1.01. What is the ratio of the Electricity production(% of total) in Greece in 2003 to that in 2004?
Your answer should be very brief. 1.01. What is the ratio of the Electricity production(% of total) in Guatemala in 2003 to that in 2004?
Provide a short and direct response. 0.94. What is the ratio of the Electricity production(% of total) in Thailand in 2003 to that in 2004?
Offer a terse response. 1.01. What is the difference between the highest and the second highest Electricity production(% of total) in World?
Ensure brevity in your answer.  0.52. What is the difference between the highest and the second highest Electricity production(% of total) in Guatemala?
Your answer should be very brief. 1.29. What is the difference between the highest and the second highest Electricity production(% of total) in Thailand?
Give a very brief answer. 0.88. What is the difference between the highest and the lowest Electricity production(% of total) in World?
Provide a short and direct response. 2.19. What is the difference between the highest and the lowest Electricity production(% of total) of Greece?
Give a very brief answer. 6.6. What is the difference between the highest and the lowest Electricity production(% of total) in Guatemala?
Offer a terse response. 15.06. What is the difference between the highest and the lowest Electricity production(% of total) of Thailand?
Keep it short and to the point. 3.01. 